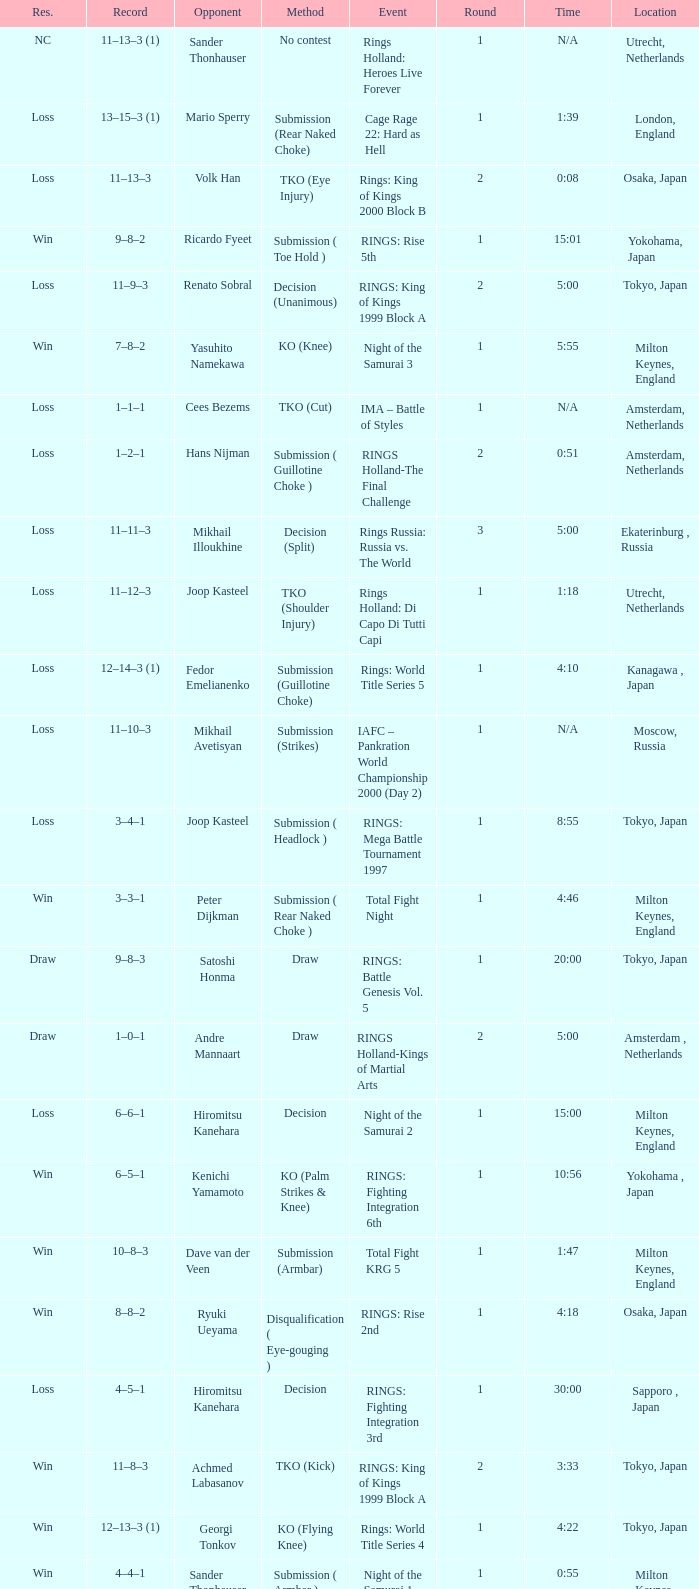What is the time for Moscow, Russia? N/A. 